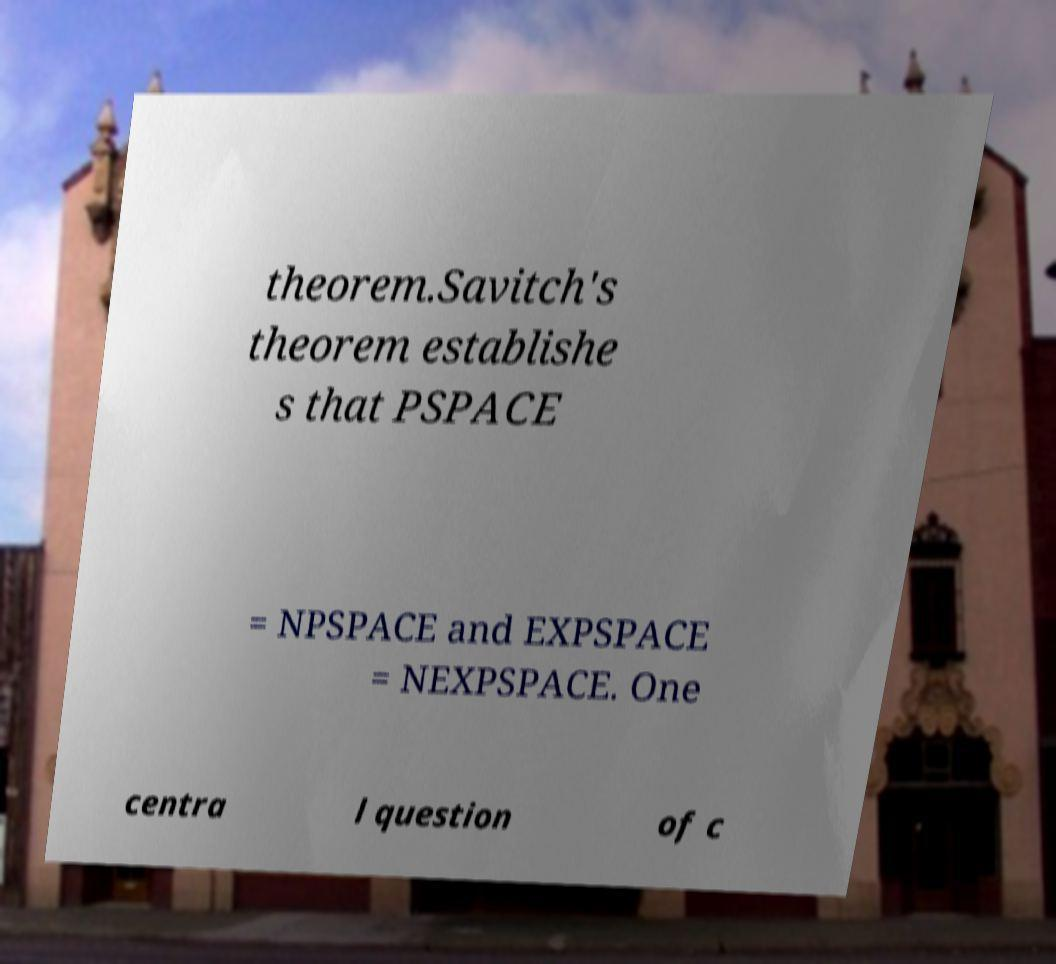Can you read and provide the text displayed in the image?This photo seems to have some interesting text. Can you extract and type it out for me? theorem.Savitch's theorem establishe s that PSPACE = NPSPACE and EXPSPACE = NEXPSPACE. One centra l question of c 